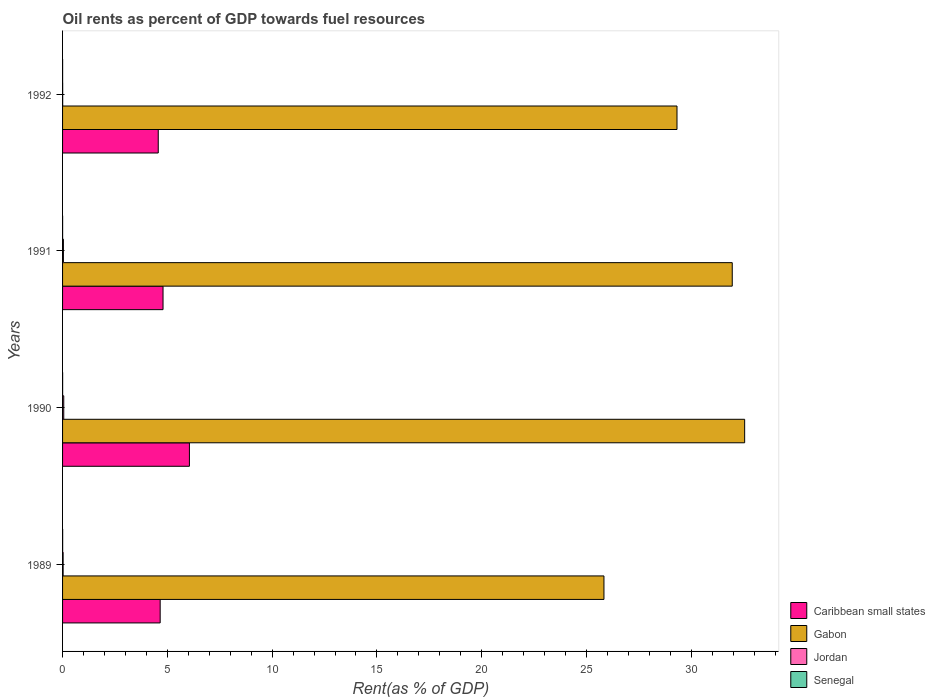How many groups of bars are there?
Provide a succinct answer. 4. How many bars are there on the 2nd tick from the top?
Offer a very short reply. 4. How many bars are there on the 2nd tick from the bottom?
Offer a very short reply. 4. What is the oil rent in Senegal in 1991?
Provide a succinct answer. 0. Across all years, what is the maximum oil rent in Gabon?
Make the answer very short. 32.55. Across all years, what is the minimum oil rent in Caribbean small states?
Your response must be concise. 4.57. In which year was the oil rent in Caribbean small states maximum?
Provide a succinct answer. 1990. What is the total oil rent in Senegal in the graph?
Your response must be concise. 0.01. What is the difference between the oil rent in Senegal in 1990 and that in 1992?
Offer a very short reply. 0. What is the difference between the oil rent in Gabon in 1992 and the oil rent in Senegal in 1991?
Your answer should be very brief. 29.32. What is the average oil rent in Jordan per year?
Your answer should be very brief. 0.03. In the year 1992, what is the difference between the oil rent in Senegal and oil rent in Caribbean small states?
Your response must be concise. -4.56. What is the ratio of the oil rent in Caribbean small states in 1990 to that in 1991?
Make the answer very short. 1.26. What is the difference between the highest and the second highest oil rent in Gabon?
Give a very brief answer. 0.59. What is the difference between the highest and the lowest oil rent in Jordan?
Your answer should be very brief. 0.05. What does the 3rd bar from the top in 1991 represents?
Give a very brief answer. Gabon. What does the 1st bar from the bottom in 1991 represents?
Ensure brevity in your answer.  Caribbean small states. Is it the case that in every year, the sum of the oil rent in Senegal and oil rent in Jordan is greater than the oil rent in Gabon?
Offer a terse response. No. Are all the bars in the graph horizontal?
Keep it short and to the point. Yes. Does the graph contain grids?
Your answer should be compact. No. Where does the legend appear in the graph?
Offer a very short reply. Bottom right. What is the title of the graph?
Keep it short and to the point. Oil rents as percent of GDP towards fuel resources. Does "European Union" appear as one of the legend labels in the graph?
Make the answer very short. No. What is the label or title of the X-axis?
Provide a succinct answer. Rent(as % of GDP). What is the label or title of the Y-axis?
Make the answer very short. Years. What is the Rent(as % of GDP) in Caribbean small states in 1989?
Ensure brevity in your answer.  4.66. What is the Rent(as % of GDP) of Gabon in 1989?
Offer a terse response. 25.83. What is the Rent(as % of GDP) of Jordan in 1989?
Offer a very short reply. 0.03. What is the Rent(as % of GDP) in Senegal in 1989?
Your answer should be very brief. 0. What is the Rent(as % of GDP) of Caribbean small states in 1990?
Ensure brevity in your answer.  6.05. What is the Rent(as % of GDP) in Gabon in 1990?
Keep it short and to the point. 32.55. What is the Rent(as % of GDP) of Jordan in 1990?
Your answer should be compact. 0.06. What is the Rent(as % of GDP) of Senegal in 1990?
Provide a succinct answer. 0. What is the Rent(as % of GDP) of Caribbean small states in 1991?
Give a very brief answer. 4.79. What is the Rent(as % of GDP) in Gabon in 1991?
Provide a succinct answer. 31.96. What is the Rent(as % of GDP) of Jordan in 1991?
Give a very brief answer. 0.04. What is the Rent(as % of GDP) of Senegal in 1991?
Your answer should be very brief. 0. What is the Rent(as % of GDP) of Caribbean small states in 1992?
Give a very brief answer. 4.57. What is the Rent(as % of GDP) of Gabon in 1992?
Provide a short and direct response. 29.32. What is the Rent(as % of GDP) in Jordan in 1992?
Make the answer very short. 0.01. What is the Rent(as % of GDP) in Senegal in 1992?
Provide a short and direct response. 0. Across all years, what is the maximum Rent(as % of GDP) in Caribbean small states?
Your response must be concise. 6.05. Across all years, what is the maximum Rent(as % of GDP) of Gabon?
Your answer should be very brief. 32.55. Across all years, what is the maximum Rent(as % of GDP) in Jordan?
Offer a very short reply. 0.06. Across all years, what is the maximum Rent(as % of GDP) of Senegal?
Your response must be concise. 0. Across all years, what is the minimum Rent(as % of GDP) in Caribbean small states?
Give a very brief answer. 4.57. Across all years, what is the minimum Rent(as % of GDP) of Gabon?
Keep it short and to the point. 25.83. Across all years, what is the minimum Rent(as % of GDP) in Jordan?
Your answer should be compact. 0.01. Across all years, what is the minimum Rent(as % of GDP) of Senegal?
Give a very brief answer. 0. What is the total Rent(as % of GDP) in Caribbean small states in the graph?
Your answer should be compact. 20.07. What is the total Rent(as % of GDP) in Gabon in the graph?
Ensure brevity in your answer.  119.66. What is the total Rent(as % of GDP) in Jordan in the graph?
Ensure brevity in your answer.  0.13. What is the total Rent(as % of GDP) in Senegal in the graph?
Your answer should be very brief. 0.01. What is the difference between the Rent(as % of GDP) in Caribbean small states in 1989 and that in 1990?
Offer a very short reply. -1.4. What is the difference between the Rent(as % of GDP) in Gabon in 1989 and that in 1990?
Give a very brief answer. -6.71. What is the difference between the Rent(as % of GDP) of Jordan in 1989 and that in 1990?
Keep it short and to the point. -0.03. What is the difference between the Rent(as % of GDP) in Senegal in 1989 and that in 1990?
Offer a very short reply. 0. What is the difference between the Rent(as % of GDP) of Caribbean small states in 1989 and that in 1991?
Provide a succinct answer. -0.14. What is the difference between the Rent(as % of GDP) of Gabon in 1989 and that in 1991?
Provide a succinct answer. -6.12. What is the difference between the Rent(as % of GDP) of Jordan in 1989 and that in 1991?
Provide a succinct answer. -0.01. What is the difference between the Rent(as % of GDP) of Senegal in 1989 and that in 1991?
Your response must be concise. 0. What is the difference between the Rent(as % of GDP) in Caribbean small states in 1989 and that in 1992?
Give a very brief answer. 0.09. What is the difference between the Rent(as % of GDP) in Gabon in 1989 and that in 1992?
Give a very brief answer. -3.49. What is the difference between the Rent(as % of GDP) in Jordan in 1989 and that in 1992?
Keep it short and to the point. 0.02. What is the difference between the Rent(as % of GDP) of Senegal in 1989 and that in 1992?
Your answer should be compact. 0. What is the difference between the Rent(as % of GDP) in Caribbean small states in 1990 and that in 1991?
Offer a very short reply. 1.26. What is the difference between the Rent(as % of GDP) of Gabon in 1990 and that in 1991?
Your answer should be very brief. 0.59. What is the difference between the Rent(as % of GDP) of Jordan in 1990 and that in 1991?
Your answer should be very brief. 0.02. What is the difference between the Rent(as % of GDP) of Senegal in 1990 and that in 1991?
Ensure brevity in your answer.  0. What is the difference between the Rent(as % of GDP) in Caribbean small states in 1990 and that in 1992?
Give a very brief answer. 1.49. What is the difference between the Rent(as % of GDP) of Gabon in 1990 and that in 1992?
Provide a succinct answer. 3.23. What is the difference between the Rent(as % of GDP) in Jordan in 1990 and that in 1992?
Provide a succinct answer. 0.05. What is the difference between the Rent(as % of GDP) of Senegal in 1990 and that in 1992?
Ensure brevity in your answer.  0. What is the difference between the Rent(as % of GDP) of Caribbean small states in 1991 and that in 1992?
Offer a terse response. 0.23. What is the difference between the Rent(as % of GDP) of Gabon in 1991 and that in 1992?
Provide a succinct answer. 2.64. What is the difference between the Rent(as % of GDP) in Jordan in 1991 and that in 1992?
Give a very brief answer. 0.04. What is the difference between the Rent(as % of GDP) in Senegal in 1991 and that in 1992?
Give a very brief answer. 0. What is the difference between the Rent(as % of GDP) of Caribbean small states in 1989 and the Rent(as % of GDP) of Gabon in 1990?
Your answer should be very brief. -27.89. What is the difference between the Rent(as % of GDP) in Caribbean small states in 1989 and the Rent(as % of GDP) in Jordan in 1990?
Offer a terse response. 4.6. What is the difference between the Rent(as % of GDP) of Caribbean small states in 1989 and the Rent(as % of GDP) of Senegal in 1990?
Offer a very short reply. 4.66. What is the difference between the Rent(as % of GDP) in Gabon in 1989 and the Rent(as % of GDP) in Jordan in 1990?
Make the answer very short. 25.78. What is the difference between the Rent(as % of GDP) in Gabon in 1989 and the Rent(as % of GDP) in Senegal in 1990?
Your answer should be compact. 25.83. What is the difference between the Rent(as % of GDP) in Jordan in 1989 and the Rent(as % of GDP) in Senegal in 1990?
Keep it short and to the point. 0.02. What is the difference between the Rent(as % of GDP) in Caribbean small states in 1989 and the Rent(as % of GDP) in Gabon in 1991?
Keep it short and to the point. -27.3. What is the difference between the Rent(as % of GDP) in Caribbean small states in 1989 and the Rent(as % of GDP) in Jordan in 1991?
Make the answer very short. 4.62. What is the difference between the Rent(as % of GDP) in Caribbean small states in 1989 and the Rent(as % of GDP) in Senegal in 1991?
Offer a very short reply. 4.66. What is the difference between the Rent(as % of GDP) in Gabon in 1989 and the Rent(as % of GDP) in Jordan in 1991?
Provide a succinct answer. 25.79. What is the difference between the Rent(as % of GDP) of Gabon in 1989 and the Rent(as % of GDP) of Senegal in 1991?
Provide a short and direct response. 25.83. What is the difference between the Rent(as % of GDP) in Jordan in 1989 and the Rent(as % of GDP) in Senegal in 1991?
Your answer should be compact. 0.02. What is the difference between the Rent(as % of GDP) of Caribbean small states in 1989 and the Rent(as % of GDP) of Gabon in 1992?
Make the answer very short. -24.66. What is the difference between the Rent(as % of GDP) in Caribbean small states in 1989 and the Rent(as % of GDP) in Jordan in 1992?
Offer a very short reply. 4.65. What is the difference between the Rent(as % of GDP) of Caribbean small states in 1989 and the Rent(as % of GDP) of Senegal in 1992?
Give a very brief answer. 4.66. What is the difference between the Rent(as % of GDP) in Gabon in 1989 and the Rent(as % of GDP) in Jordan in 1992?
Offer a very short reply. 25.83. What is the difference between the Rent(as % of GDP) in Gabon in 1989 and the Rent(as % of GDP) in Senegal in 1992?
Make the answer very short. 25.83. What is the difference between the Rent(as % of GDP) of Jordan in 1989 and the Rent(as % of GDP) of Senegal in 1992?
Your answer should be very brief. 0.02. What is the difference between the Rent(as % of GDP) in Caribbean small states in 1990 and the Rent(as % of GDP) in Gabon in 1991?
Your response must be concise. -25.9. What is the difference between the Rent(as % of GDP) in Caribbean small states in 1990 and the Rent(as % of GDP) in Jordan in 1991?
Your answer should be very brief. 6.01. What is the difference between the Rent(as % of GDP) of Caribbean small states in 1990 and the Rent(as % of GDP) of Senegal in 1991?
Your answer should be compact. 6.05. What is the difference between the Rent(as % of GDP) in Gabon in 1990 and the Rent(as % of GDP) in Jordan in 1991?
Your response must be concise. 32.51. What is the difference between the Rent(as % of GDP) in Gabon in 1990 and the Rent(as % of GDP) in Senegal in 1991?
Offer a terse response. 32.55. What is the difference between the Rent(as % of GDP) in Jordan in 1990 and the Rent(as % of GDP) in Senegal in 1991?
Your response must be concise. 0.05. What is the difference between the Rent(as % of GDP) in Caribbean small states in 1990 and the Rent(as % of GDP) in Gabon in 1992?
Your answer should be compact. -23.27. What is the difference between the Rent(as % of GDP) in Caribbean small states in 1990 and the Rent(as % of GDP) in Jordan in 1992?
Your answer should be very brief. 6.05. What is the difference between the Rent(as % of GDP) of Caribbean small states in 1990 and the Rent(as % of GDP) of Senegal in 1992?
Your answer should be very brief. 6.05. What is the difference between the Rent(as % of GDP) in Gabon in 1990 and the Rent(as % of GDP) in Jordan in 1992?
Your response must be concise. 32.54. What is the difference between the Rent(as % of GDP) of Gabon in 1990 and the Rent(as % of GDP) of Senegal in 1992?
Make the answer very short. 32.55. What is the difference between the Rent(as % of GDP) of Jordan in 1990 and the Rent(as % of GDP) of Senegal in 1992?
Your answer should be very brief. 0.05. What is the difference between the Rent(as % of GDP) of Caribbean small states in 1991 and the Rent(as % of GDP) of Gabon in 1992?
Your response must be concise. -24.53. What is the difference between the Rent(as % of GDP) of Caribbean small states in 1991 and the Rent(as % of GDP) of Jordan in 1992?
Ensure brevity in your answer.  4.79. What is the difference between the Rent(as % of GDP) of Caribbean small states in 1991 and the Rent(as % of GDP) of Senegal in 1992?
Ensure brevity in your answer.  4.79. What is the difference between the Rent(as % of GDP) in Gabon in 1991 and the Rent(as % of GDP) in Jordan in 1992?
Keep it short and to the point. 31.95. What is the difference between the Rent(as % of GDP) of Gabon in 1991 and the Rent(as % of GDP) of Senegal in 1992?
Offer a very short reply. 31.95. What is the difference between the Rent(as % of GDP) in Jordan in 1991 and the Rent(as % of GDP) in Senegal in 1992?
Provide a succinct answer. 0.04. What is the average Rent(as % of GDP) of Caribbean small states per year?
Your answer should be very brief. 5.02. What is the average Rent(as % of GDP) of Gabon per year?
Provide a short and direct response. 29.91. What is the average Rent(as % of GDP) in Jordan per year?
Make the answer very short. 0.03. What is the average Rent(as % of GDP) of Senegal per year?
Provide a short and direct response. 0. In the year 1989, what is the difference between the Rent(as % of GDP) in Caribbean small states and Rent(as % of GDP) in Gabon?
Offer a very short reply. -21.18. In the year 1989, what is the difference between the Rent(as % of GDP) of Caribbean small states and Rent(as % of GDP) of Jordan?
Ensure brevity in your answer.  4.63. In the year 1989, what is the difference between the Rent(as % of GDP) in Caribbean small states and Rent(as % of GDP) in Senegal?
Keep it short and to the point. 4.65. In the year 1989, what is the difference between the Rent(as % of GDP) of Gabon and Rent(as % of GDP) of Jordan?
Your answer should be compact. 25.81. In the year 1989, what is the difference between the Rent(as % of GDP) of Gabon and Rent(as % of GDP) of Senegal?
Provide a succinct answer. 25.83. In the year 1989, what is the difference between the Rent(as % of GDP) of Jordan and Rent(as % of GDP) of Senegal?
Make the answer very short. 0.02. In the year 1990, what is the difference between the Rent(as % of GDP) of Caribbean small states and Rent(as % of GDP) of Gabon?
Your answer should be very brief. -26.5. In the year 1990, what is the difference between the Rent(as % of GDP) in Caribbean small states and Rent(as % of GDP) in Jordan?
Offer a terse response. 6. In the year 1990, what is the difference between the Rent(as % of GDP) of Caribbean small states and Rent(as % of GDP) of Senegal?
Your answer should be compact. 6.05. In the year 1990, what is the difference between the Rent(as % of GDP) in Gabon and Rent(as % of GDP) in Jordan?
Provide a short and direct response. 32.49. In the year 1990, what is the difference between the Rent(as % of GDP) of Gabon and Rent(as % of GDP) of Senegal?
Provide a succinct answer. 32.55. In the year 1990, what is the difference between the Rent(as % of GDP) of Jordan and Rent(as % of GDP) of Senegal?
Provide a short and direct response. 0.05. In the year 1991, what is the difference between the Rent(as % of GDP) in Caribbean small states and Rent(as % of GDP) in Gabon?
Give a very brief answer. -27.16. In the year 1991, what is the difference between the Rent(as % of GDP) of Caribbean small states and Rent(as % of GDP) of Jordan?
Provide a short and direct response. 4.75. In the year 1991, what is the difference between the Rent(as % of GDP) in Caribbean small states and Rent(as % of GDP) in Senegal?
Give a very brief answer. 4.79. In the year 1991, what is the difference between the Rent(as % of GDP) in Gabon and Rent(as % of GDP) in Jordan?
Give a very brief answer. 31.92. In the year 1991, what is the difference between the Rent(as % of GDP) in Gabon and Rent(as % of GDP) in Senegal?
Make the answer very short. 31.95. In the year 1991, what is the difference between the Rent(as % of GDP) of Jordan and Rent(as % of GDP) of Senegal?
Offer a terse response. 0.04. In the year 1992, what is the difference between the Rent(as % of GDP) in Caribbean small states and Rent(as % of GDP) in Gabon?
Your answer should be compact. -24.75. In the year 1992, what is the difference between the Rent(as % of GDP) of Caribbean small states and Rent(as % of GDP) of Jordan?
Ensure brevity in your answer.  4.56. In the year 1992, what is the difference between the Rent(as % of GDP) of Caribbean small states and Rent(as % of GDP) of Senegal?
Your answer should be compact. 4.56. In the year 1992, what is the difference between the Rent(as % of GDP) in Gabon and Rent(as % of GDP) in Jordan?
Keep it short and to the point. 29.31. In the year 1992, what is the difference between the Rent(as % of GDP) of Gabon and Rent(as % of GDP) of Senegal?
Your response must be concise. 29.32. In the year 1992, what is the difference between the Rent(as % of GDP) of Jordan and Rent(as % of GDP) of Senegal?
Keep it short and to the point. 0. What is the ratio of the Rent(as % of GDP) of Caribbean small states in 1989 to that in 1990?
Make the answer very short. 0.77. What is the ratio of the Rent(as % of GDP) of Gabon in 1989 to that in 1990?
Ensure brevity in your answer.  0.79. What is the ratio of the Rent(as % of GDP) of Jordan in 1989 to that in 1990?
Offer a very short reply. 0.48. What is the ratio of the Rent(as % of GDP) of Senegal in 1989 to that in 1990?
Your response must be concise. 1.71. What is the ratio of the Rent(as % of GDP) of Caribbean small states in 1989 to that in 1991?
Keep it short and to the point. 0.97. What is the ratio of the Rent(as % of GDP) of Gabon in 1989 to that in 1991?
Your answer should be very brief. 0.81. What is the ratio of the Rent(as % of GDP) in Jordan in 1989 to that in 1991?
Your response must be concise. 0.66. What is the ratio of the Rent(as % of GDP) of Senegal in 1989 to that in 1991?
Your answer should be very brief. 2.06. What is the ratio of the Rent(as % of GDP) in Caribbean small states in 1989 to that in 1992?
Your answer should be very brief. 1.02. What is the ratio of the Rent(as % of GDP) of Gabon in 1989 to that in 1992?
Keep it short and to the point. 0.88. What is the ratio of the Rent(as % of GDP) of Jordan in 1989 to that in 1992?
Your answer should be compact. 5.03. What is the ratio of the Rent(as % of GDP) in Senegal in 1989 to that in 1992?
Provide a succinct answer. 2.28. What is the ratio of the Rent(as % of GDP) in Caribbean small states in 1990 to that in 1991?
Keep it short and to the point. 1.26. What is the ratio of the Rent(as % of GDP) in Gabon in 1990 to that in 1991?
Give a very brief answer. 1.02. What is the ratio of the Rent(as % of GDP) in Jordan in 1990 to that in 1991?
Ensure brevity in your answer.  1.39. What is the ratio of the Rent(as % of GDP) of Senegal in 1990 to that in 1991?
Give a very brief answer. 1.2. What is the ratio of the Rent(as % of GDP) of Caribbean small states in 1990 to that in 1992?
Make the answer very short. 1.33. What is the ratio of the Rent(as % of GDP) in Gabon in 1990 to that in 1992?
Your answer should be very brief. 1.11. What is the ratio of the Rent(as % of GDP) of Jordan in 1990 to that in 1992?
Give a very brief answer. 10.55. What is the ratio of the Rent(as % of GDP) in Senegal in 1990 to that in 1992?
Provide a succinct answer. 1.33. What is the ratio of the Rent(as % of GDP) of Gabon in 1991 to that in 1992?
Offer a very short reply. 1.09. What is the ratio of the Rent(as % of GDP) in Jordan in 1991 to that in 1992?
Offer a terse response. 7.57. What is the ratio of the Rent(as % of GDP) of Senegal in 1991 to that in 1992?
Make the answer very short. 1.11. What is the difference between the highest and the second highest Rent(as % of GDP) of Caribbean small states?
Your answer should be compact. 1.26. What is the difference between the highest and the second highest Rent(as % of GDP) of Gabon?
Provide a short and direct response. 0.59. What is the difference between the highest and the second highest Rent(as % of GDP) of Jordan?
Your response must be concise. 0.02. What is the difference between the highest and the second highest Rent(as % of GDP) of Senegal?
Make the answer very short. 0. What is the difference between the highest and the lowest Rent(as % of GDP) of Caribbean small states?
Provide a short and direct response. 1.49. What is the difference between the highest and the lowest Rent(as % of GDP) of Gabon?
Your answer should be very brief. 6.71. What is the difference between the highest and the lowest Rent(as % of GDP) in Jordan?
Your answer should be compact. 0.05. What is the difference between the highest and the lowest Rent(as % of GDP) of Senegal?
Provide a succinct answer. 0. 